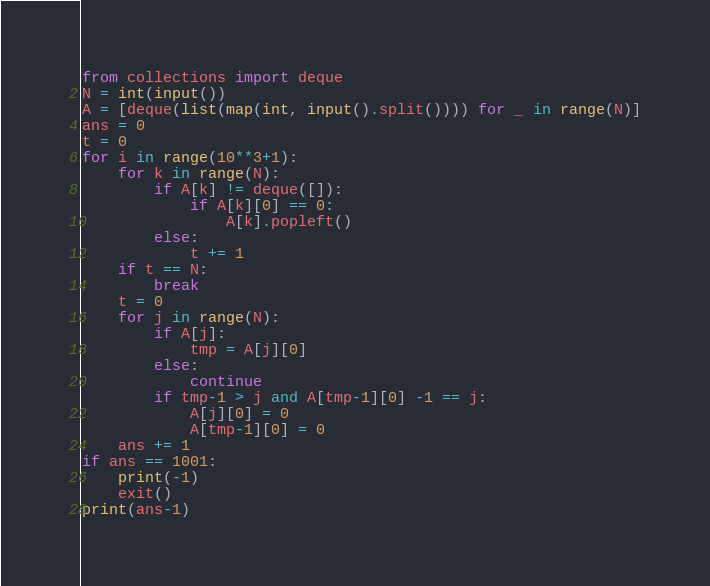Convert code to text. <code><loc_0><loc_0><loc_500><loc_500><_Python_>from collections import deque
N = int(input())
A = [deque(list(map(int, input().split()))) for _ in range(N)]
ans = 0
t = 0
for i in range(10**3+1):
    for k in range(N):
        if A[k] != deque([]):
            if A[k][0] == 0:
                A[k].popleft()
        else:
            t += 1
    if t == N:
        break
    t = 0
    for j in range(N):
        if A[j]:
            tmp = A[j][0]
        else:
            continue
        if tmp-1 > j and A[tmp-1][0] -1 == j:
            A[j][0] = 0
            A[tmp-1][0] = 0
    ans += 1
if ans == 1001:
    print(-1)
    exit()
print(ans-1)</code> 